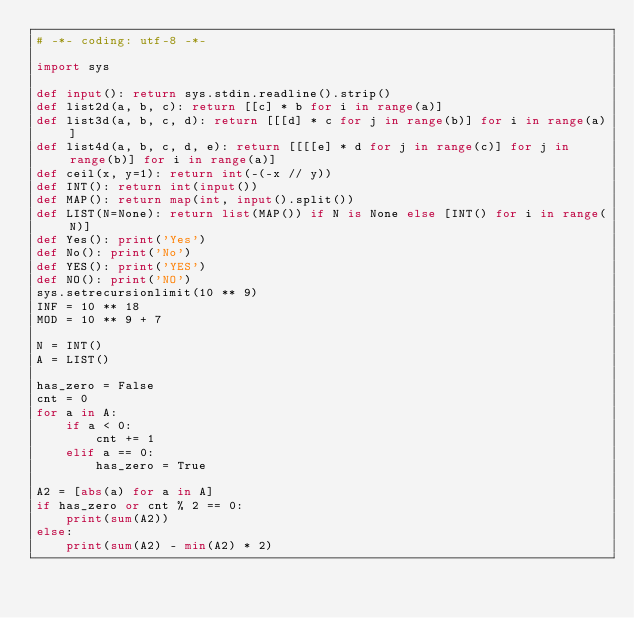Convert code to text. <code><loc_0><loc_0><loc_500><loc_500><_Python_># -*- coding: utf-8 -*-

import sys

def input(): return sys.stdin.readline().strip()
def list2d(a, b, c): return [[c] * b for i in range(a)]
def list3d(a, b, c, d): return [[[d] * c for j in range(b)] for i in range(a)]
def list4d(a, b, c, d, e): return [[[[e] * d for j in range(c)] for j in range(b)] for i in range(a)]
def ceil(x, y=1): return int(-(-x // y))
def INT(): return int(input())
def MAP(): return map(int, input().split())
def LIST(N=None): return list(MAP()) if N is None else [INT() for i in range(N)]
def Yes(): print('Yes')
def No(): print('No')
def YES(): print('YES')
def NO(): print('NO')
sys.setrecursionlimit(10 ** 9)
INF = 10 ** 18
MOD = 10 ** 9 + 7

N = INT()
A = LIST()

has_zero = False
cnt = 0
for a in A:
    if a < 0:
        cnt += 1
    elif a == 0:
        has_zero = True

A2 = [abs(a) for a in A]
if has_zero or cnt % 2 == 0:
    print(sum(A2))
else:
    print(sum(A2) - min(A2) * 2)
</code> 